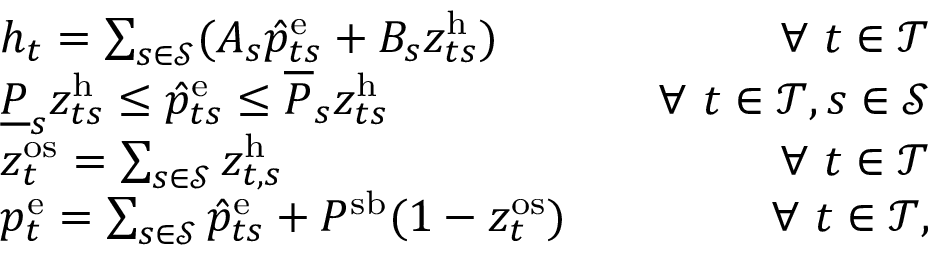Convert formula to latex. <formula><loc_0><loc_0><loc_500><loc_500>\begin{array} { r l r } & { h _ { t } = \sum _ { s \in \mathcal { S } } ( A _ { s } \hat { p } _ { t s } ^ { e } + B _ { s } z _ { t s } ^ { h } ) } & { \quad \forall t \in \mathcal { T } } \\ & { \underline { P } _ { s } z _ { t s } ^ { h } \leq \hat { p } _ { t s } ^ { e } \leq \overline { P } _ { s } z _ { t s } ^ { h } } & { \quad \forall t \in \mathcal { T } , s \in \mathcal { S } } \\ & { z _ { t } ^ { o s } = \sum _ { s \in \mathcal { S } } z _ { t , s } ^ { h } } & { \quad \forall t \in \mathcal { T } } \\ & { p _ { t } ^ { e } = \sum _ { s \in \mathcal { S } } \hat { p } _ { t s } ^ { e } + P ^ { s b } ( 1 - z _ { t } ^ { o s } ) } & { \forall t \in \mathcal { T } , } \end{array}</formula> 